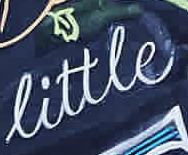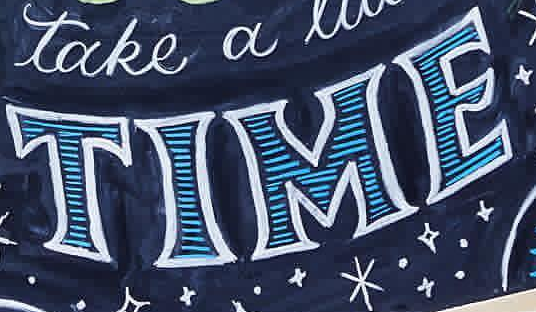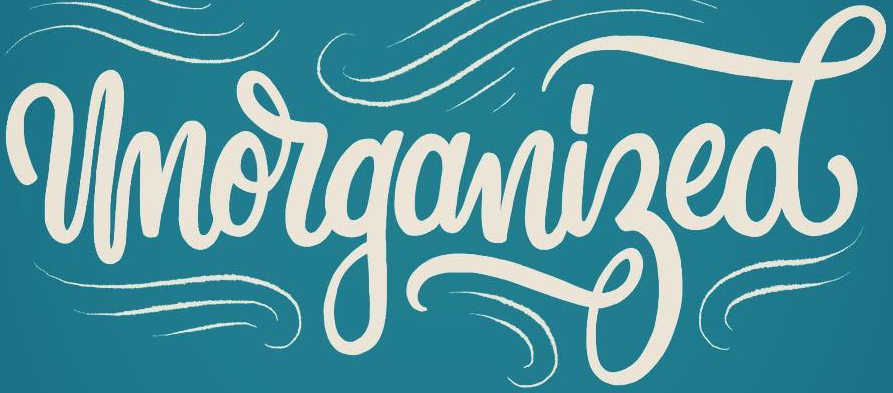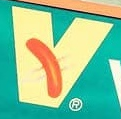What words can you see in these images in sequence, separated by a semicolon? little; TIME; Unorganized; v 